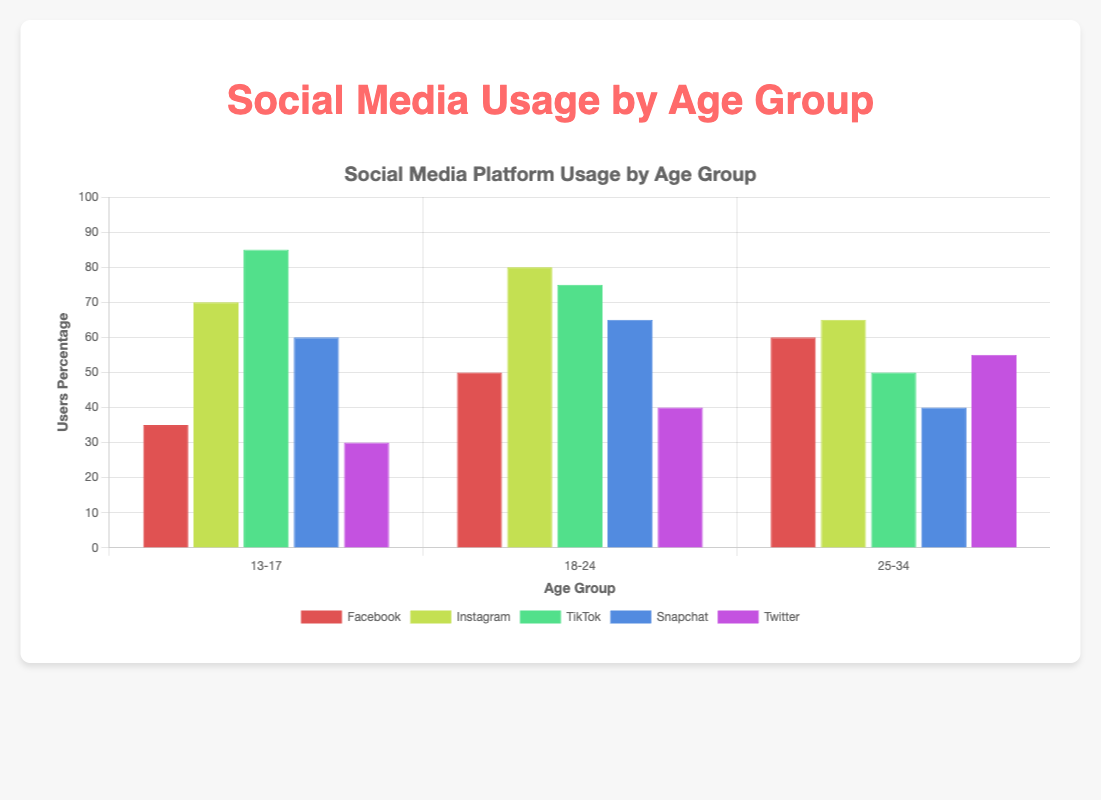What age group has the highest user percentage on TikTok? The highest bar for TikTok is in the 13-17 age group, which has the highest user percentage.
Answer: 13-17 Which platform has the most daily engagement minutes for the 18-24 age group? Comparing the height of the bars for daily engagement in the 18-24 age group shows TikTok has the highest engagement.
Answer: TikTok How does the user percentage for Instagram in the 25-34 age group compare to Facebook in the same age group? The bar for Instagram in the 25-34 age group is slightly lower than Facebook. Instagram has 65% while Facebook has 60%.
Answer: Instagram has a higher percentage What is the difference in daily engagement minutes between Snapchat and Twitter for the 13-17 age group? The bar for Snapchat in the 13-17 age group reaches 35 daily engagement minutes, while Twitter reaches 15. The difference is 35 - 15.
Answer: 20 minutes What is the total user percentage for Facebook across all age groups? Sum the heights of the bars for Facebook across all age groups. That's 35 (13-17) + 50 (18-24) + 60 (25-34).
Answer: 145% Which platform has the least user percentage in the 13-17 age group, and what is that percentage? The shortest bar in the 13-17 age group is for Twitter.
Answer: Twitter, 30% Which platform has the highest daily engagement on average across all age groups? Calculate the average engagement for each platform: TikTok [60+55+40]=155/3, Instagram [40+45+35]=120/3, Facebook [10+20+25]=55/3, Snapchat [35+30+20]=85/3, Twitter [15+20+25]=60/3. TikTok has the highest average.
Answer: TikTok How does the engagement of Facebook in the 18-24 age group compare to Instagram in the same age group? Facebook in the 18-24 age group is 20 minutes, while Instagram is 45 minutes. Instagram is 25 minutes more.
Answer: Instagram has 25 minutes more Which age group has the highest engagement with Instagram, and what is the engagement in minutes? The tallest bar for Instagram engagement is in the 18-24 age group, at 45 minutes.
Answer: 18-24, 45 minutes What is the difference in user percentage between Snapchat and TikTok for the 25-34 age group? The user percentage for Snapchat in the 25-34 age group is 40%, and for TikTok, it is 50%. The difference is 50% - 40%.
Answer: 10% 